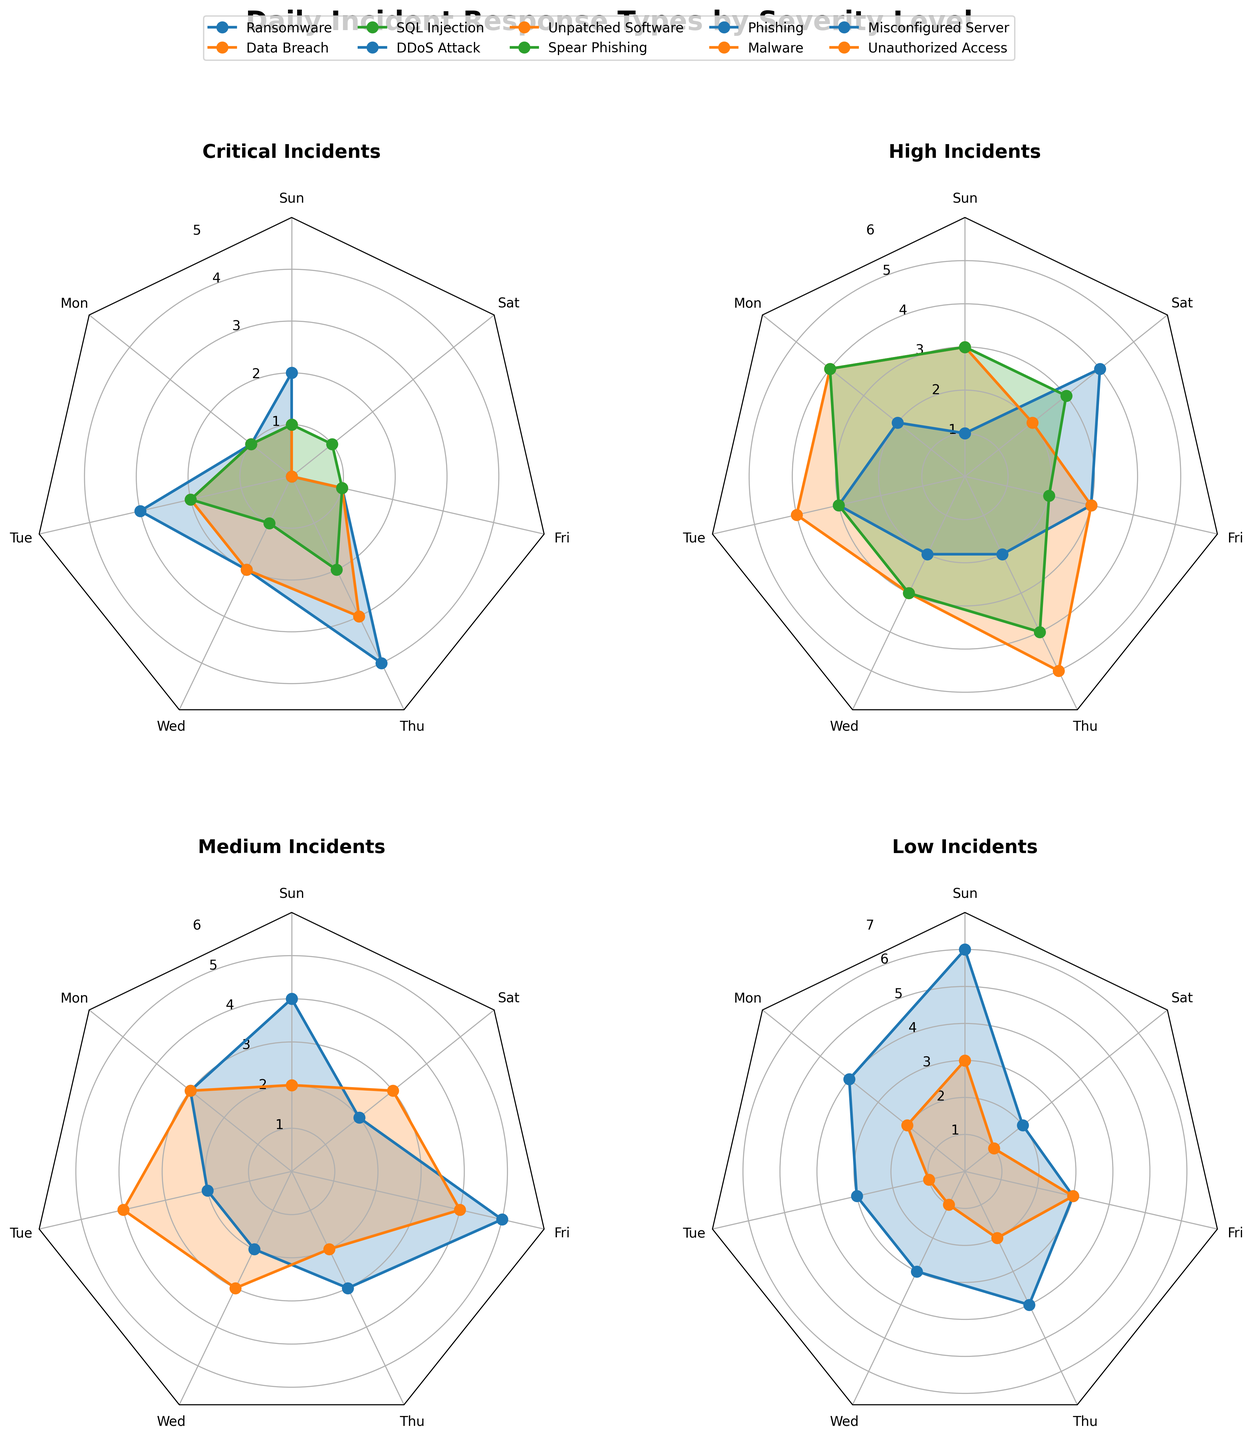Which severity level has the highest number of 'Data Breach' incidents on Thursday? We look at the 'Critical' subplot and identify the value for 'Data Breach' incidents on Thursday. It is 3. This is the only severity level for 'Data Breach'.
Answer: 3 What is the average number of 'Phishing' incidents across the week? The 'Phishing' subplot under 'Medium' shows daily values: 4, 3, 2, 2, 3, 5, 2. Summing these, we get 21; there are 7 days, so the average is 21/7.
Answer: 3 Which day has the fewest 'Ransomware' incidents in the 'Critical' severity level? In the 'Critical' subplot, the day with the lowest number of 'Ransomware' incidents is Saturday, with 0 incidents.
Answer: Saturday How do the 'DDoS Attack' incidents on Tuesday compare to the same incident type on Sunday? In the 'High' severity subplot, 'DDoS Attack' has 3 incidents on Tuesday and 1 incident on Sunday. Comparing these, Tuesday is greater than Sunday.
Answer: Tuesday What is the maximum number of incidents for 'Misconfigured Server' in any given day? In the 'Low' severity subplot, the highest value for 'Misconfigured Server' is 6 on Sunday.
Answer: 6 Between 'Malware' and 'Spear Phishing' incidents in 'High' severity level, which has the highest total incidents across the week? Summing up the values in the 'High' severity level: 'Spear Phishing' (3+4+3+3+4+2+3 = 22) and 'Malware' in 'Medium' (2+3+4+3+2+4+3 = 21). 'Spear Phishing' has more.
Answer: Spear Phishing On which day does the 'High' severity level have the most number of incidents for 'Unpatched Software'? 'Unpatched Software' in 'High' severity has the highest value of 5 on Thursday.
Answer: Thursday 